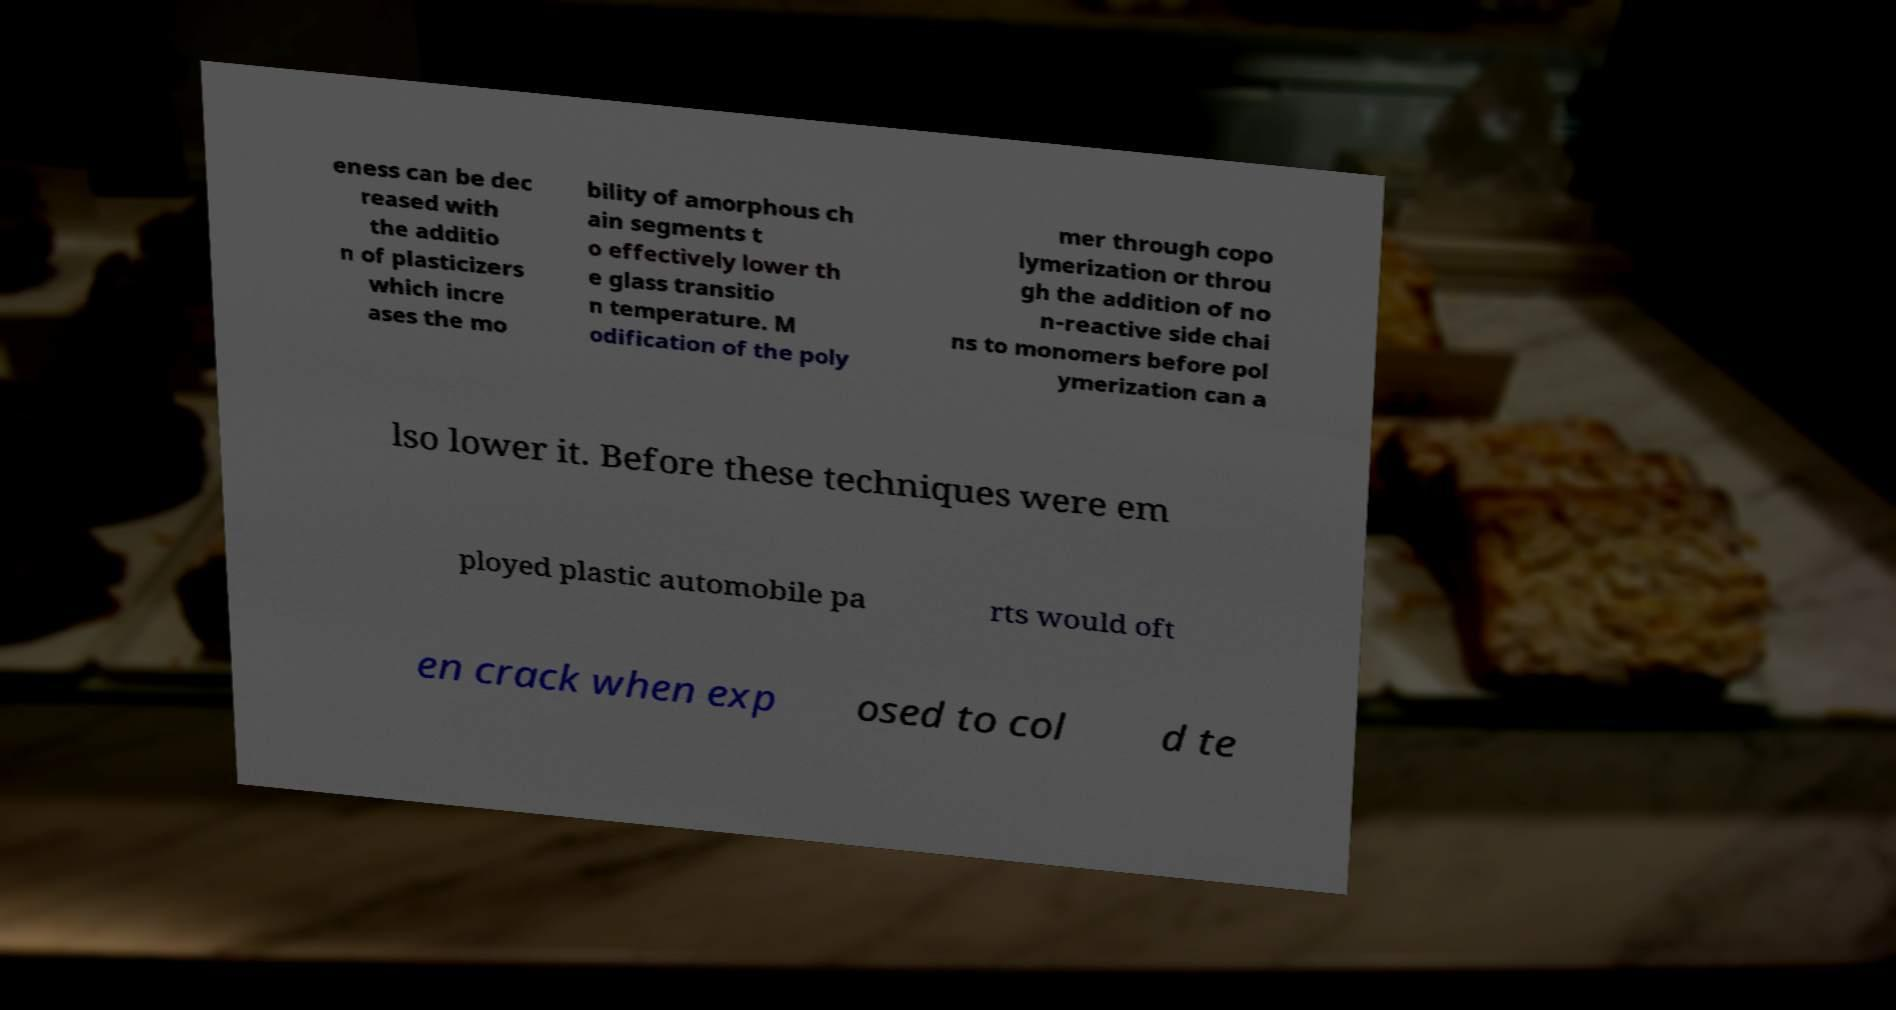Can you accurately transcribe the text from the provided image for me? eness can be dec reased with the additio n of plasticizers which incre ases the mo bility of amorphous ch ain segments t o effectively lower th e glass transitio n temperature. M odification of the poly mer through copo lymerization or throu gh the addition of no n-reactive side chai ns to monomers before pol ymerization can a lso lower it. Before these techniques were em ployed plastic automobile pa rts would oft en crack when exp osed to col d te 